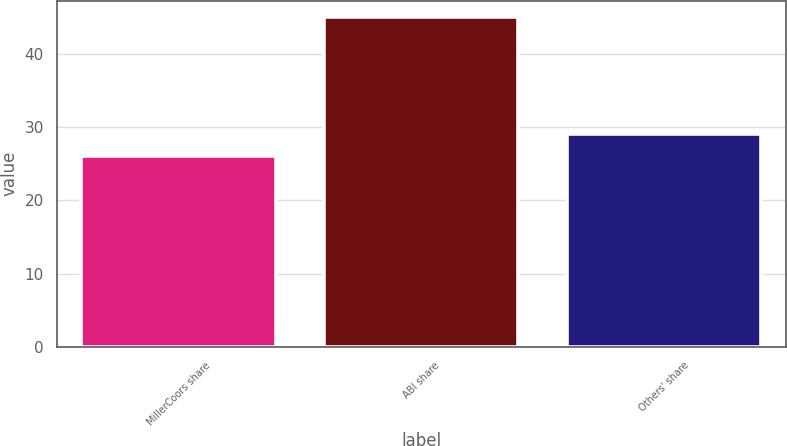Convert chart to OTSL. <chart><loc_0><loc_0><loc_500><loc_500><bar_chart><fcel>MillerCoors share<fcel>ABI share<fcel>Others' share<nl><fcel>26<fcel>45<fcel>29<nl></chart> 